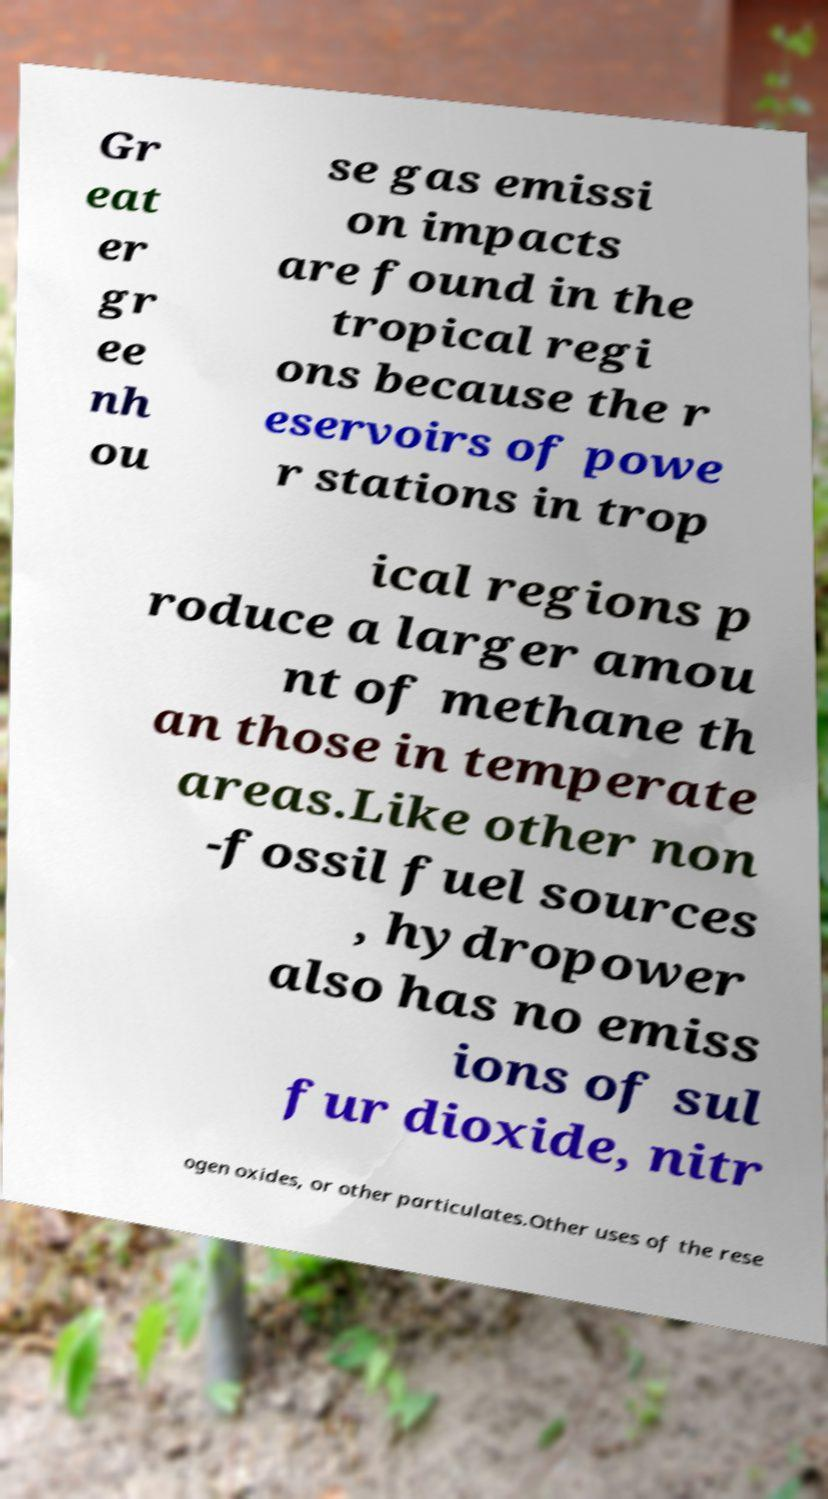Can you read and provide the text displayed in the image?This photo seems to have some interesting text. Can you extract and type it out for me? Gr eat er gr ee nh ou se gas emissi on impacts are found in the tropical regi ons because the r eservoirs of powe r stations in trop ical regions p roduce a larger amou nt of methane th an those in temperate areas.Like other non -fossil fuel sources , hydropower also has no emiss ions of sul fur dioxide, nitr ogen oxides, or other particulates.Other uses of the rese 